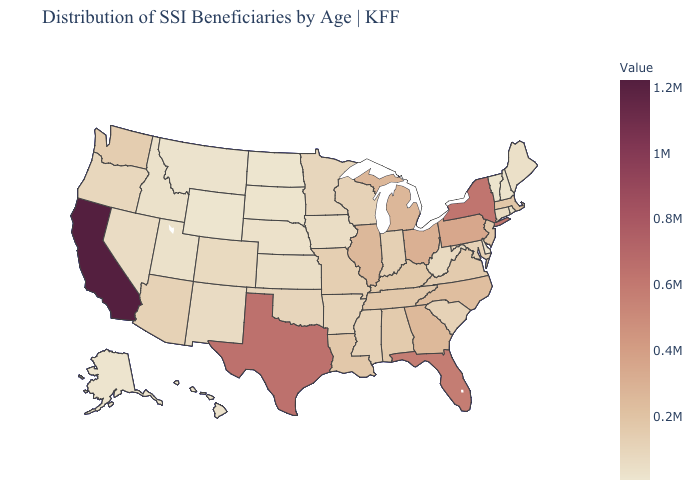Does Wyoming have the lowest value in the West?
Give a very brief answer. Yes. Among the states that border Arkansas , does Oklahoma have the lowest value?
Keep it brief. Yes. Is the legend a continuous bar?
Short answer required. Yes. Which states hav the highest value in the West?
Write a very short answer. California. 